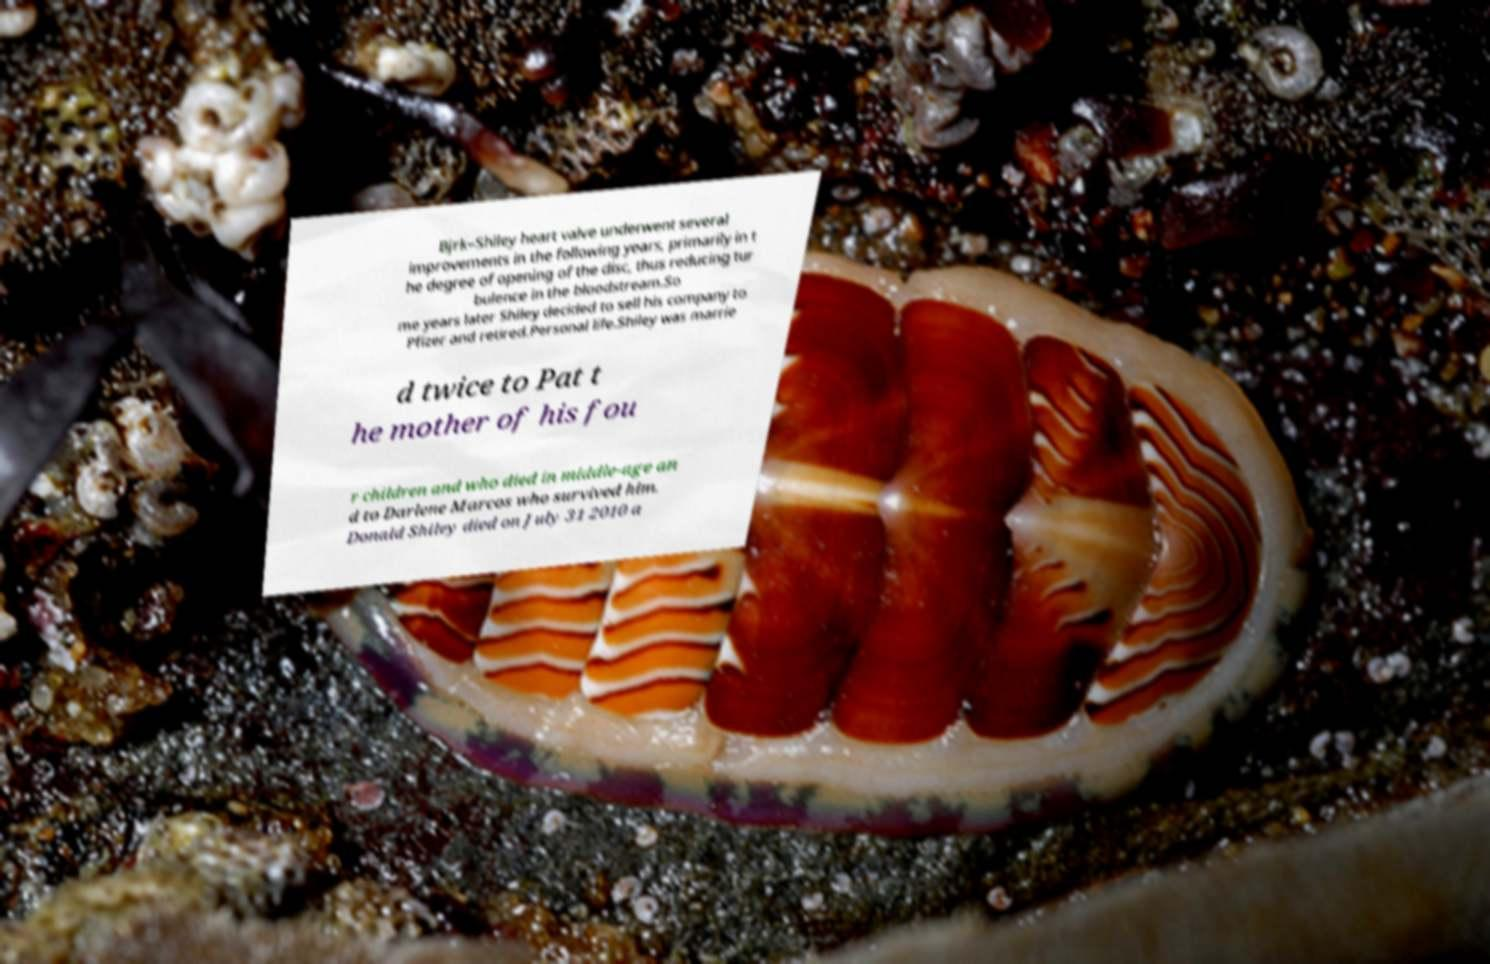What messages or text are displayed in this image? I need them in a readable, typed format. Bjrk–Shiley heart valve underwent several improvements in the following years, primarily in t he degree of opening of the disc, thus reducing tur bulence in the bloodstream.So me years later Shiley decided to sell his company to Pfizer and retired.Personal life.Shiley was marrie d twice to Pat t he mother of his fou r children and who died in middle-age an d to Darlene Marcos who survived him. Donald Shiley died on July 31 2010 a 